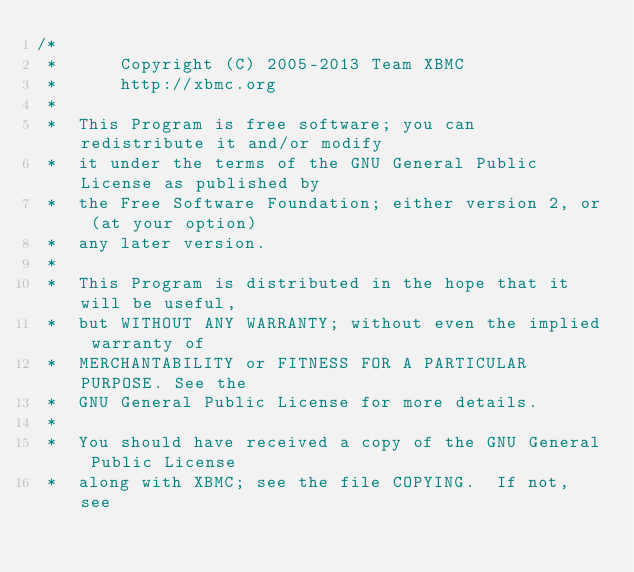Convert code to text. <code><loc_0><loc_0><loc_500><loc_500><_C++_>/*
 *      Copyright (C) 2005-2013 Team XBMC
 *      http://xbmc.org
 *
 *  This Program is free software; you can redistribute it and/or modify
 *  it under the terms of the GNU General Public License as published by
 *  the Free Software Foundation; either version 2, or (at your option)
 *  any later version.
 *
 *  This Program is distributed in the hope that it will be useful,
 *  but WITHOUT ANY WARRANTY; without even the implied warranty of
 *  MERCHANTABILITY or FITNESS FOR A PARTICULAR PURPOSE. See the
 *  GNU General Public License for more details.
 *
 *  You should have received a copy of the GNU General Public License
 *  along with XBMC; see the file COPYING.  If not, see</code> 